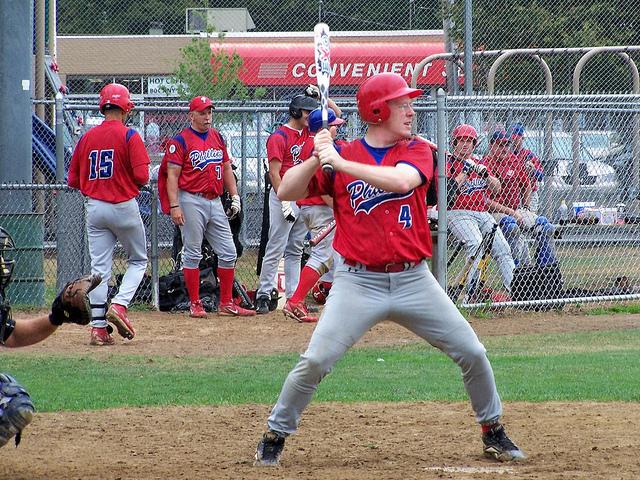How many people are holding bats?
Answer briefly. 2. What is the name of this hitter?
Be succinct. Bob. Could this be major league?
Concise answer only. No. Who is watching the game?
Write a very short answer. Players. What is the color of the player's uniform?
Answer briefly. Red. Whose ballpark is represented here?
Write a very short answer. Phillies. What number is on the uniform of the person at bat?
Write a very short answer. 4. What color is the player and many fans wearing?
Concise answer only. Red. What color is the top of the fence?
Give a very brief answer. Silver. Will someone be pitching the ball to the batter?
Quick response, please. Yes. 